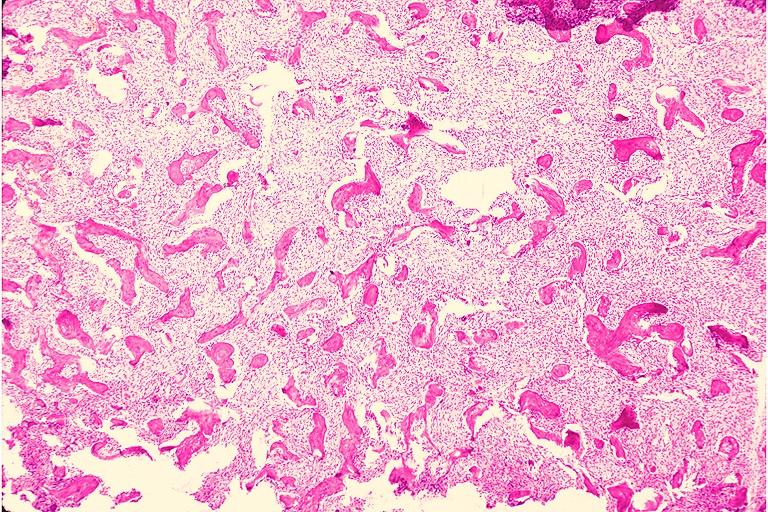does this image show fibrous dysplasia?
Answer the question using a single word or phrase. Yes 